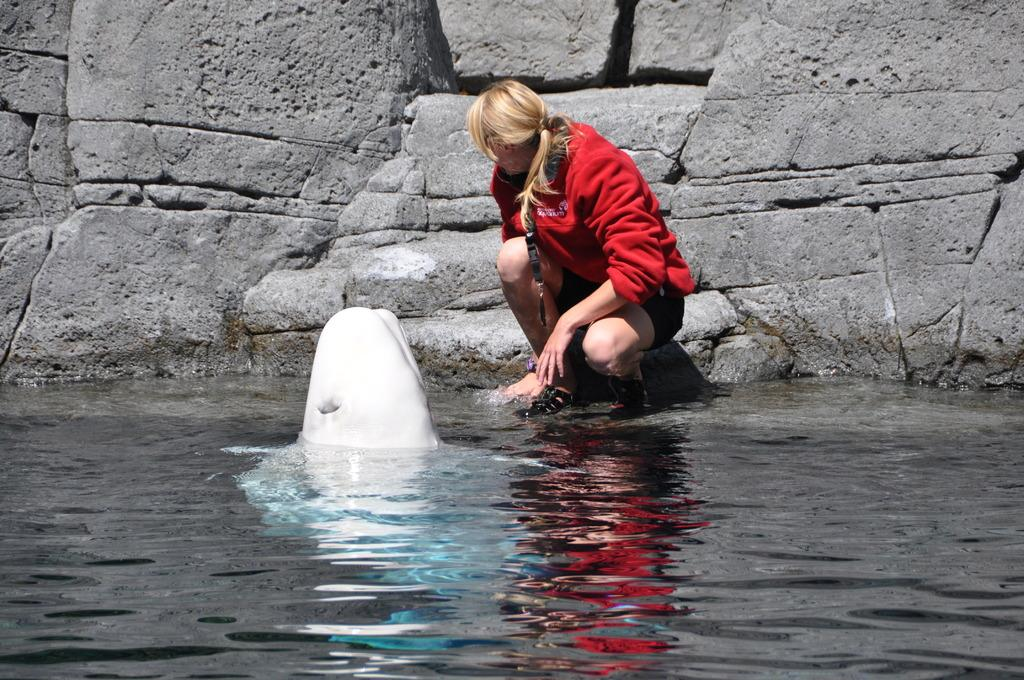What is the main subject in the center of the image? There is water in the center of the image. What type of creature can be seen in the water? There is an aquatic animal in the water. Can you describe the background of the image? There is a woman and a wall in the background of the image. What type of hole can be seen in the image? There is no hole present in the image. Is the sun visible in the image? The provided facts do not mention the sun, so we cannot determine if it is visible in the image. 